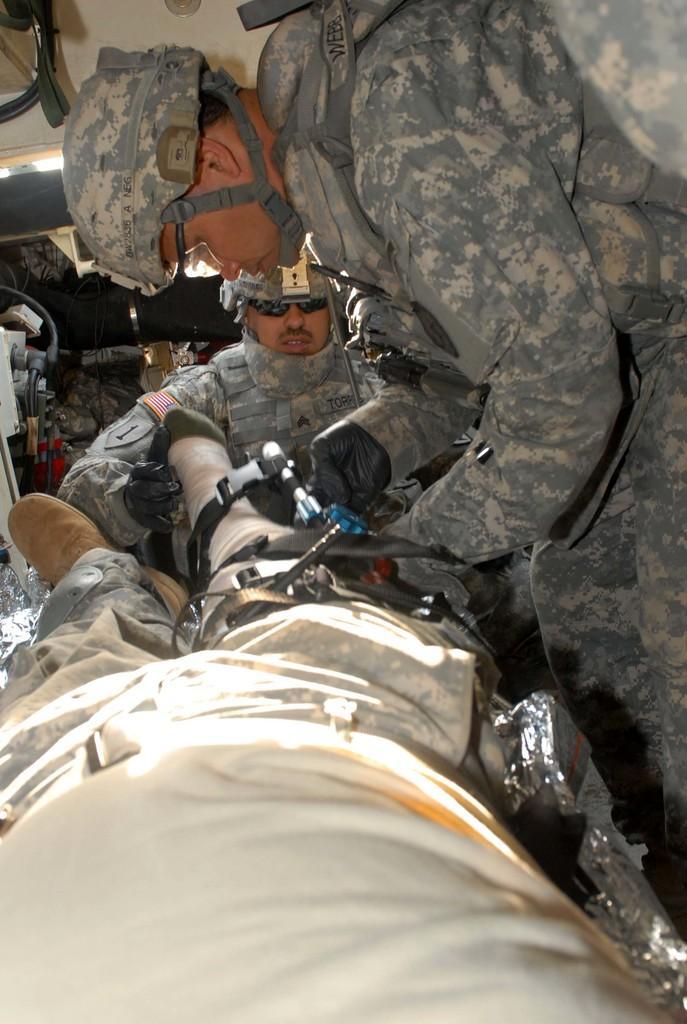Can you describe this image briefly? In this image there are two people operating a person. Behind them there are few objects. There are lights on top of the image. 